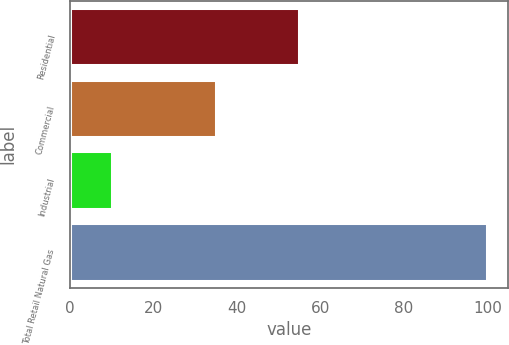<chart> <loc_0><loc_0><loc_500><loc_500><bar_chart><fcel>Residential<fcel>Commercial<fcel>Industrial<fcel>Total Retail Natural Gas<nl><fcel>55<fcel>35<fcel>10<fcel>100<nl></chart> 